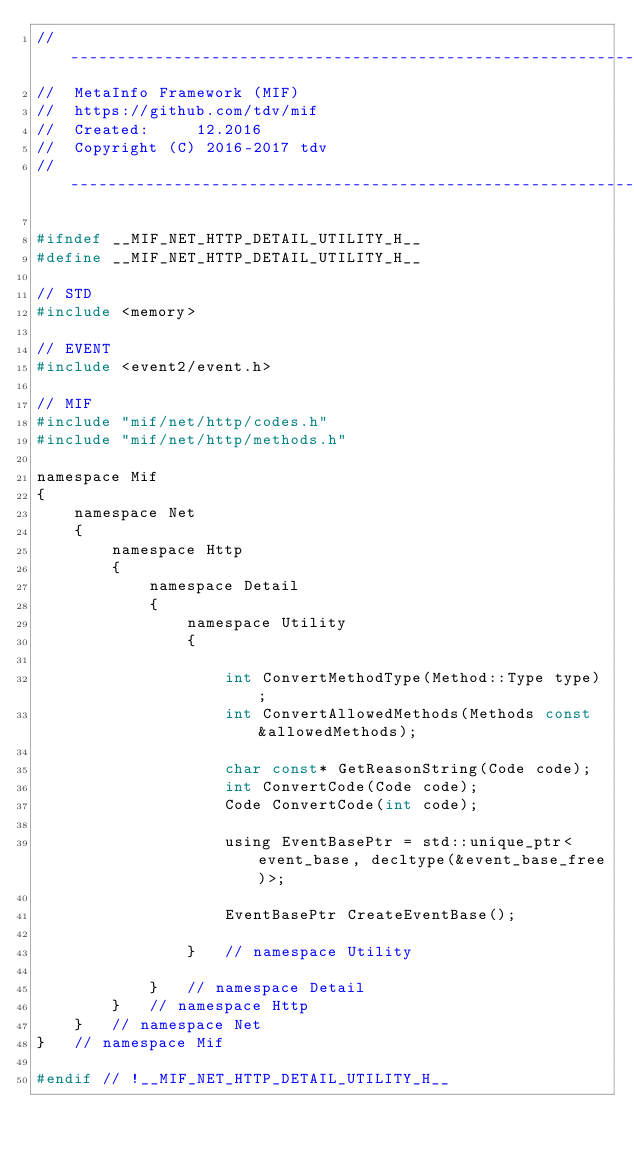Convert code to text. <code><loc_0><loc_0><loc_500><loc_500><_C_>//-------------------------------------------------------------------
//  MetaInfo Framework (MIF)
//  https://github.com/tdv/mif
//  Created:     12.2016
//  Copyright (C) 2016-2017 tdv
//-------------------------------------------------------------------

#ifndef __MIF_NET_HTTP_DETAIL_UTILITY_H__
#define __MIF_NET_HTTP_DETAIL_UTILITY_H__

// STD
#include <memory>

// EVENT
#include <event2/event.h>

// MIF
#include "mif/net/http/codes.h"
#include "mif/net/http/methods.h"

namespace Mif
{
    namespace Net
    {
        namespace Http
        {
            namespace Detail
            {
                namespace Utility
                {

                    int ConvertMethodType(Method::Type type);
                    int ConvertAllowedMethods(Methods const &allowedMethods);

                    char const* GetReasonString(Code code);
                    int ConvertCode(Code code);
                    Code ConvertCode(int code);

                    using EventBasePtr = std::unique_ptr<event_base, decltype(&event_base_free)>;

                    EventBasePtr CreateEventBase();

                }   // namespace Utility

            }   // namespace Detail
        }   // namespace Http
    }   // namespace Net
}   // namespace Mif

#endif // !__MIF_NET_HTTP_DETAIL_UTILITY_H__
</code> 